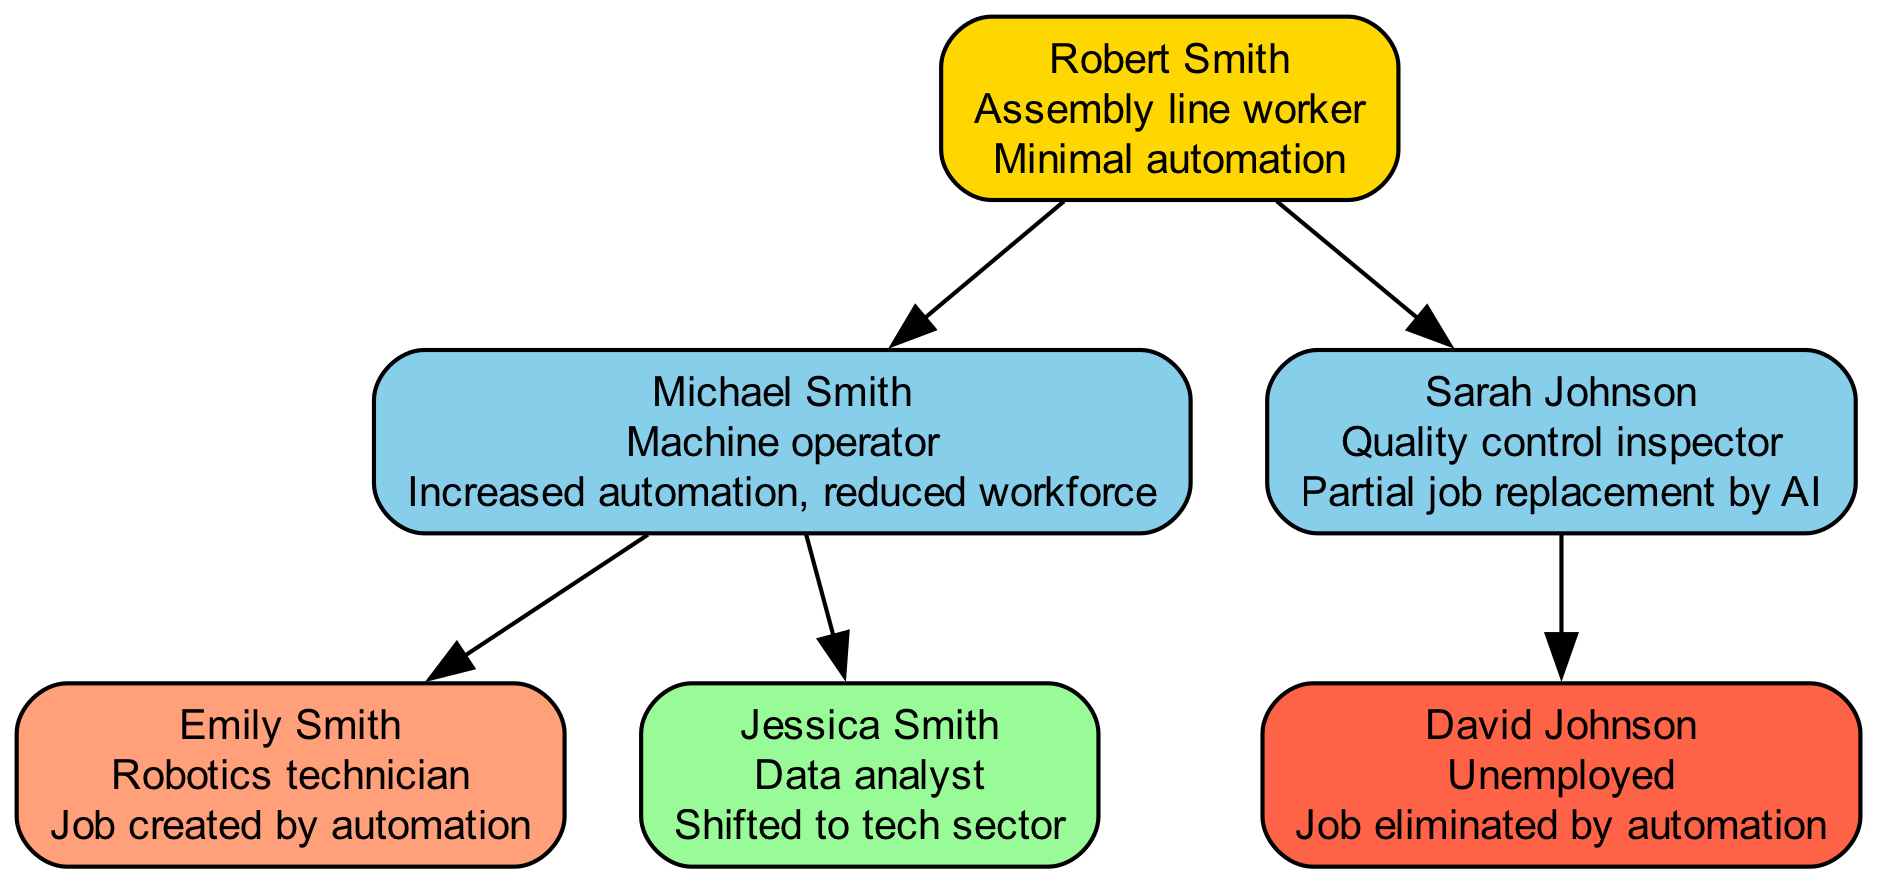What is the job of the first generation? The first generation node reveals the name and job title of the individual, which is Robert Smith as an Assembly line worker.
Answer: Assembly line worker How many people are in the second generation? Counting the nodes in the second generation reveals two individuals: Michael Smith and Sarah Johnson.
Answer: 2 What impact did Michael Smith face due to automation? The node for Michael Smith states that he experienced increased automation, reducing the workforce.
Answer: Increased automation, reduced workforce Which generation has a member that became unemployed? By reviewing the third generation nodes, it is clear that David Johnson is unemployed as noted in his job description.
Answer: Generation 3 What did Emily Smith’s job entail? The node for Emily Smith indicates that she works as a Robotics technician, a role created by automation.
Answer: Robotics technician How many connections are made from the first generation to the second generation? The first generation node connects to the two second generation nodes, forming two edges or connections.
Answer: 2 Which member of generation 3 shifted to the tech sector? Analyzing the job titles in the third generation shows Jessica Smith, who is a Data analyst, shifted to the tech sector.
Answer: Jessica Smith What is the overall impact of automation on David Johnson? The node for David Johnson clearly states that his job was eliminated by automation, indicating a negative impact.
Answer: Job eliminated by automation Which generation did job creation occur due to automation? Reviewing the information reveals that Emily Smith's position as a Robotics technician was created by automation in the third generation.
Answer: Generation 3 